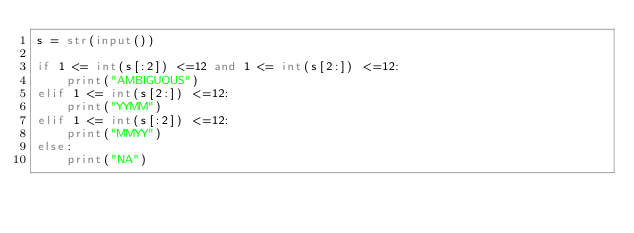Convert code to text. <code><loc_0><loc_0><loc_500><loc_500><_Python_>s = str(input())

if 1 <= int(s[:2]) <=12 and 1 <= int(s[2:]) <=12:
    print("AMBIGUOUS")
elif 1 <= int(s[2:]) <=12:
    print("YYMM")
elif 1 <= int(s[:2]) <=12:
    print("MMYY")
else:
    print("NA")


</code> 